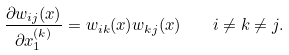<formula> <loc_0><loc_0><loc_500><loc_500>\frac { \partial w _ { i j } ( x ) } { \partial x _ { 1 } ^ { ( k ) } } = w _ { i k } ( x ) w _ { k j } ( x ) \quad i \ne k \ne j .</formula> 